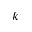Convert formula to latex. <formula><loc_0><loc_0><loc_500><loc_500>k</formula> 